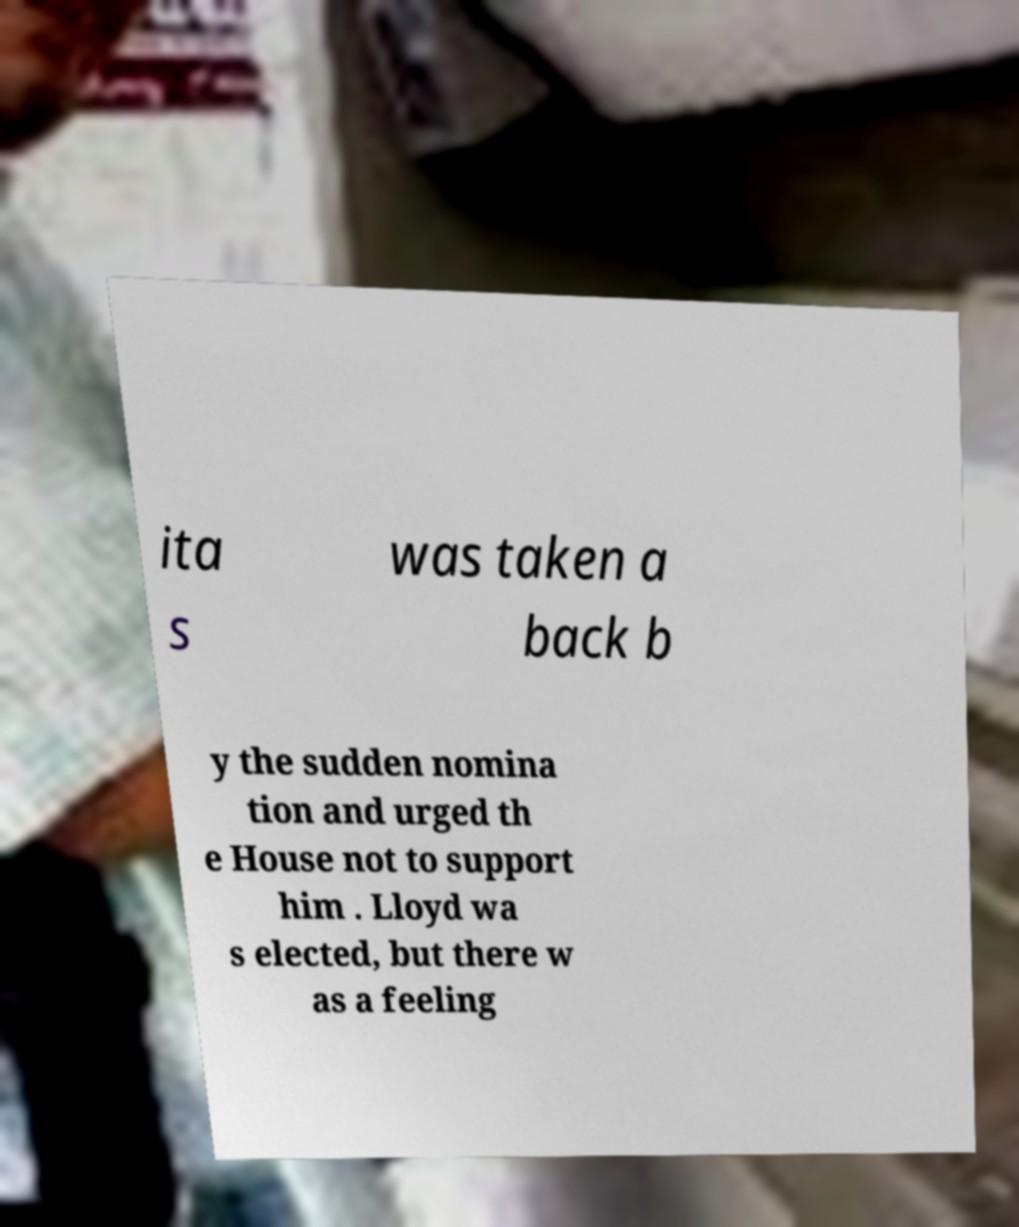What messages or text are displayed in this image? I need them in a readable, typed format. ita s was taken a back b y the sudden nomina tion and urged th e House not to support him . Lloyd wa s elected, but there w as a feeling 